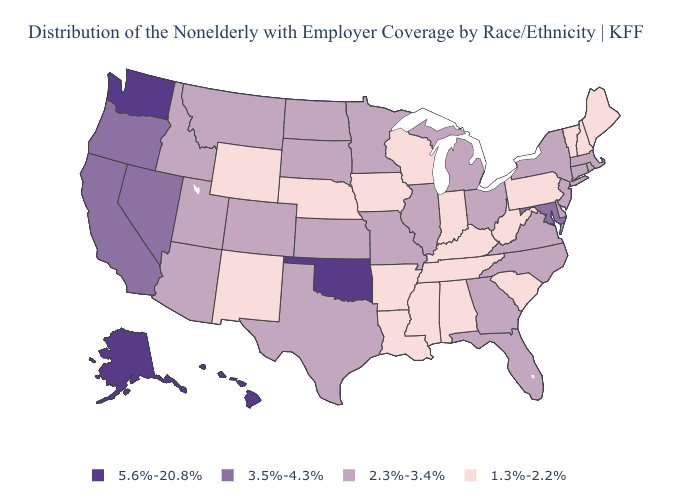What is the lowest value in states that border Wyoming?
Short answer required. 1.3%-2.2%. What is the value of Nebraska?
Short answer required. 1.3%-2.2%. Among the states that border Kentucky , which have the lowest value?
Quick response, please. Indiana, Tennessee, West Virginia. Name the states that have a value in the range 3.5%-4.3%?
Be succinct. California, Maryland, Nevada, Oregon. Is the legend a continuous bar?
Concise answer only. No. Among the states that border Oregon , does Nevada have the highest value?
Give a very brief answer. No. What is the highest value in states that border Montana?
Concise answer only. 2.3%-3.4%. Does the first symbol in the legend represent the smallest category?
Keep it brief. No. Among the states that border Iowa , which have the lowest value?
Short answer required. Nebraska, Wisconsin. Does the first symbol in the legend represent the smallest category?
Short answer required. No. Which states have the lowest value in the West?
Short answer required. New Mexico, Wyoming. What is the value of Georgia?
Short answer required. 2.3%-3.4%. Does Texas have the lowest value in the South?
Answer briefly. No. How many symbols are there in the legend?
Concise answer only. 4. What is the value of Connecticut?
Short answer required. 2.3%-3.4%. 